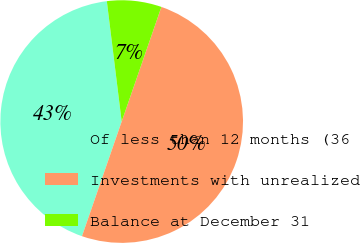Convert chart. <chart><loc_0><loc_0><loc_500><loc_500><pie_chart><fcel>Of less than 12 months (36<fcel>Investments with unrealized<fcel>Balance at December 31<nl><fcel>42.74%<fcel>50.0%<fcel>7.26%<nl></chart> 